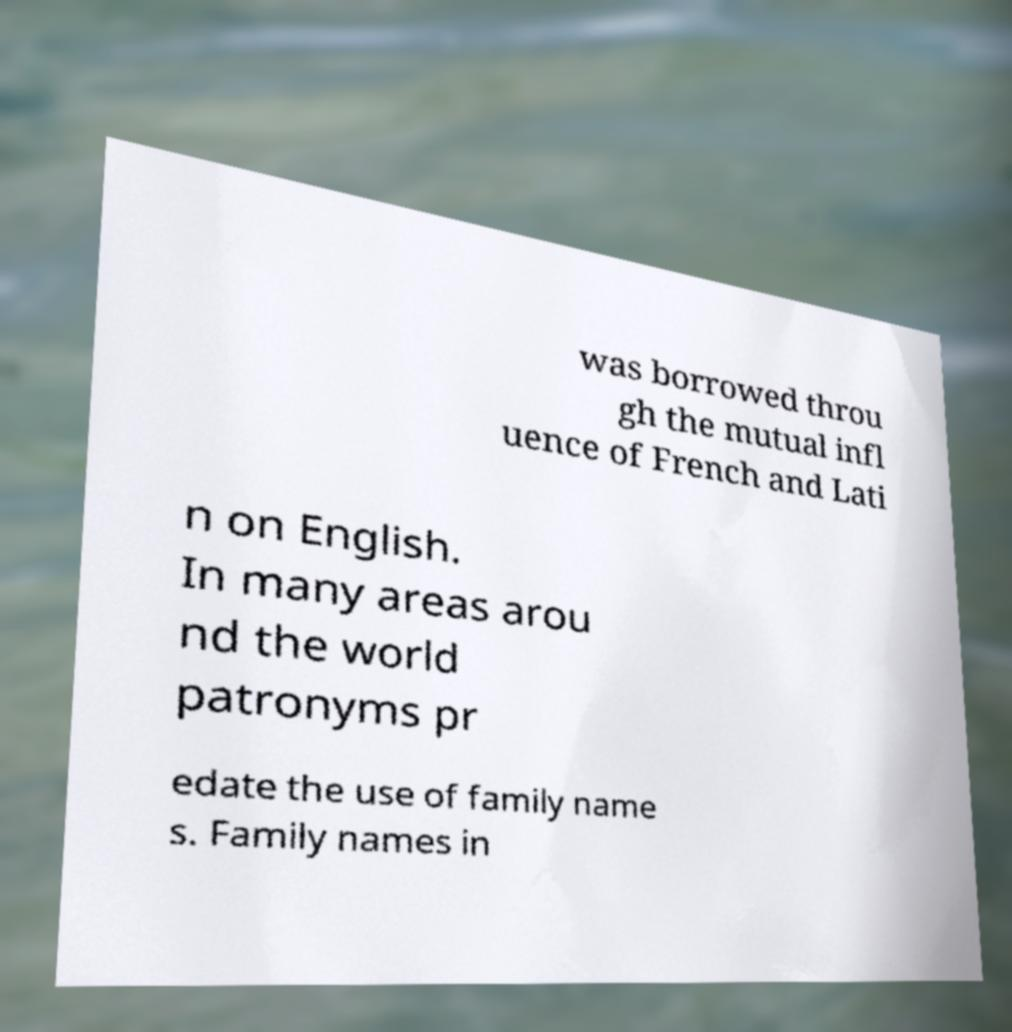What messages or text are displayed in this image? I need them in a readable, typed format. was borrowed throu gh the mutual infl uence of French and Lati n on English. In many areas arou nd the world patronyms pr edate the use of family name s. Family names in 